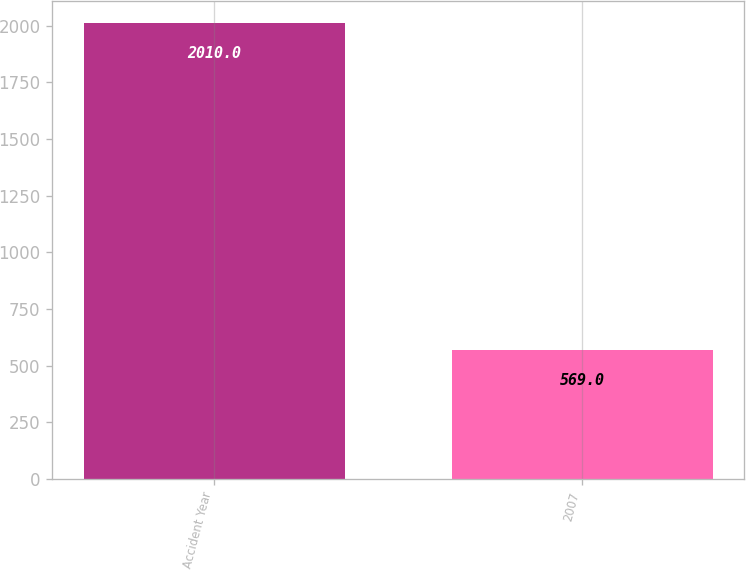<chart> <loc_0><loc_0><loc_500><loc_500><bar_chart><fcel>Accident Year<fcel>2007<nl><fcel>2010<fcel>569<nl></chart> 